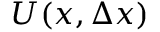<formula> <loc_0><loc_0><loc_500><loc_500>U ( x , \Delta x )</formula> 